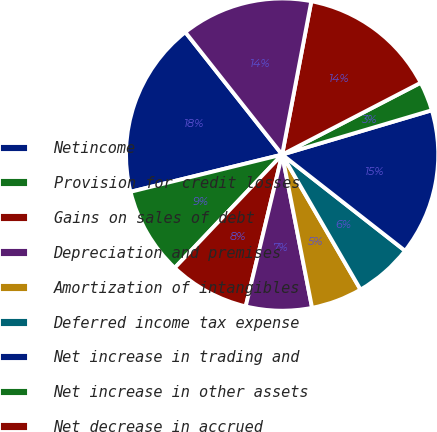Convert chart to OTSL. <chart><loc_0><loc_0><loc_500><loc_500><pie_chart><fcel>Netincome<fcel>Provision for credit losses<fcel>Gains on sales of debt<fcel>Depreciation and premises<fcel>Amortization of intangibles<fcel>Deferred income tax expense<fcel>Net increase in trading and<fcel>Net increase in other assets<fcel>Net decrease in accrued<fcel>Other operating activities net<nl><fcel>18.18%<fcel>9.09%<fcel>8.33%<fcel>6.82%<fcel>5.3%<fcel>6.06%<fcel>15.15%<fcel>3.03%<fcel>14.39%<fcel>13.64%<nl></chart> 